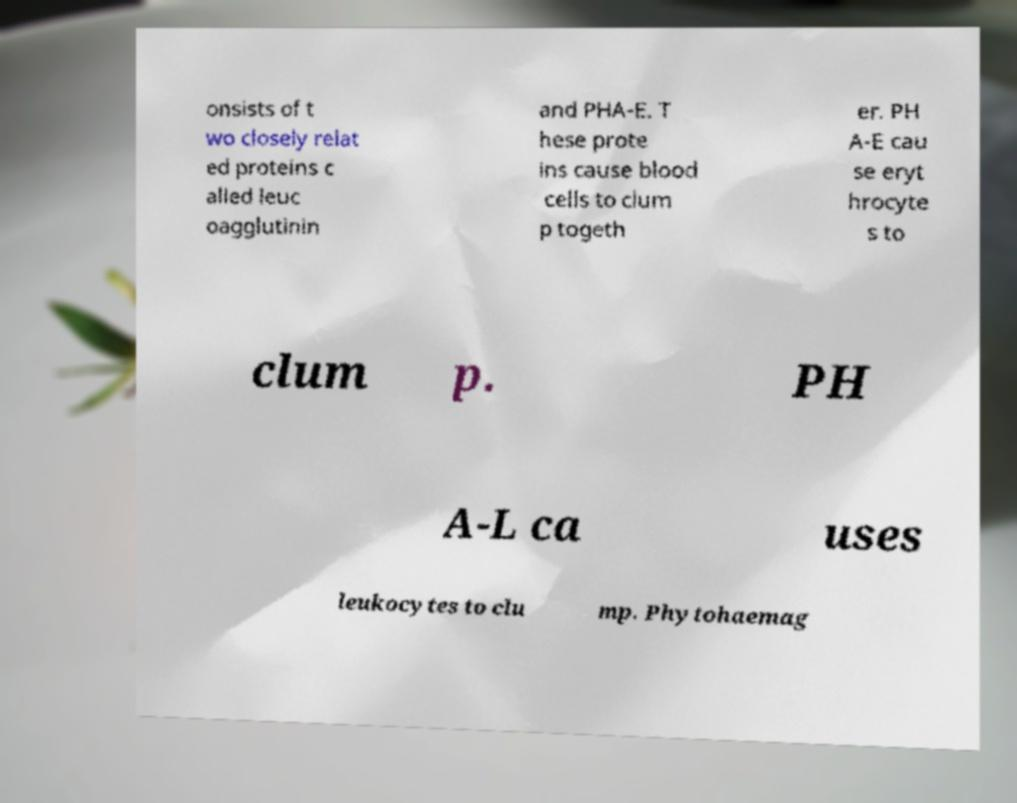Can you accurately transcribe the text from the provided image for me? onsists of t wo closely relat ed proteins c alled leuc oagglutinin and PHA-E. T hese prote ins cause blood cells to clum p togeth er. PH A-E cau se eryt hrocyte s to clum p. PH A-L ca uses leukocytes to clu mp. Phytohaemag 